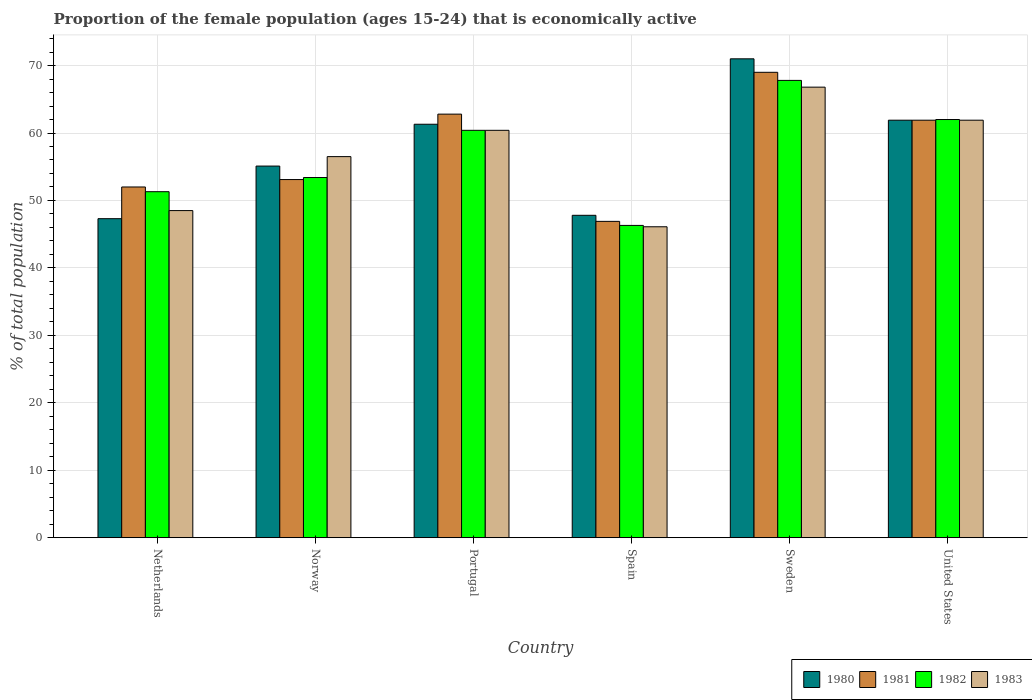Are the number of bars per tick equal to the number of legend labels?
Give a very brief answer. Yes. How many bars are there on the 1st tick from the left?
Make the answer very short. 4. What is the label of the 4th group of bars from the left?
Offer a very short reply. Spain. What is the proportion of the female population that is economically active in 1983 in Spain?
Give a very brief answer. 46.1. Across all countries, what is the maximum proportion of the female population that is economically active in 1982?
Offer a very short reply. 67.8. Across all countries, what is the minimum proportion of the female population that is economically active in 1980?
Your answer should be very brief. 47.3. What is the total proportion of the female population that is economically active in 1983 in the graph?
Make the answer very short. 340.2. What is the difference between the proportion of the female population that is economically active in 1983 in Norway and that in Portugal?
Provide a short and direct response. -3.9. What is the difference between the proportion of the female population that is economically active in 1980 in United States and the proportion of the female population that is economically active in 1981 in Sweden?
Make the answer very short. -7.1. What is the average proportion of the female population that is economically active in 1982 per country?
Make the answer very short. 56.87. What is the difference between the proportion of the female population that is economically active of/in 1980 and proportion of the female population that is economically active of/in 1982 in Sweden?
Ensure brevity in your answer.  3.2. In how many countries, is the proportion of the female population that is economically active in 1983 greater than 56 %?
Provide a short and direct response. 4. What is the ratio of the proportion of the female population that is economically active in 1983 in Portugal to that in United States?
Offer a very short reply. 0.98. Is the difference between the proportion of the female population that is economically active in 1980 in Norway and Spain greater than the difference between the proportion of the female population that is economically active in 1982 in Norway and Spain?
Offer a terse response. Yes. What is the difference between the highest and the second highest proportion of the female population that is economically active in 1980?
Keep it short and to the point. -0.6. What is the difference between the highest and the lowest proportion of the female population that is economically active in 1983?
Keep it short and to the point. 20.7. In how many countries, is the proportion of the female population that is economically active in 1981 greater than the average proportion of the female population that is economically active in 1981 taken over all countries?
Your answer should be compact. 3. Is it the case that in every country, the sum of the proportion of the female population that is economically active in 1983 and proportion of the female population that is economically active in 1980 is greater than the sum of proportion of the female population that is economically active in 1982 and proportion of the female population that is economically active in 1981?
Keep it short and to the point. No. What does the 4th bar from the right in United States represents?
Offer a terse response. 1980. How many bars are there?
Provide a short and direct response. 24. How many countries are there in the graph?
Keep it short and to the point. 6. What is the difference between two consecutive major ticks on the Y-axis?
Provide a short and direct response. 10. Does the graph contain any zero values?
Offer a terse response. No. Does the graph contain grids?
Your answer should be very brief. Yes. What is the title of the graph?
Ensure brevity in your answer.  Proportion of the female population (ages 15-24) that is economically active. Does "1961" appear as one of the legend labels in the graph?
Offer a very short reply. No. What is the label or title of the X-axis?
Your answer should be very brief. Country. What is the label or title of the Y-axis?
Give a very brief answer. % of total population. What is the % of total population in 1980 in Netherlands?
Your answer should be compact. 47.3. What is the % of total population in 1982 in Netherlands?
Give a very brief answer. 51.3. What is the % of total population in 1983 in Netherlands?
Offer a terse response. 48.5. What is the % of total population of 1980 in Norway?
Make the answer very short. 55.1. What is the % of total population of 1981 in Norway?
Your answer should be very brief. 53.1. What is the % of total population of 1982 in Norway?
Your answer should be compact. 53.4. What is the % of total population in 1983 in Norway?
Provide a succinct answer. 56.5. What is the % of total population in 1980 in Portugal?
Give a very brief answer. 61.3. What is the % of total population of 1981 in Portugal?
Offer a very short reply. 62.8. What is the % of total population of 1982 in Portugal?
Offer a terse response. 60.4. What is the % of total population in 1983 in Portugal?
Provide a succinct answer. 60.4. What is the % of total population in 1980 in Spain?
Give a very brief answer. 47.8. What is the % of total population of 1981 in Spain?
Your response must be concise. 46.9. What is the % of total population of 1982 in Spain?
Provide a short and direct response. 46.3. What is the % of total population of 1983 in Spain?
Make the answer very short. 46.1. What is the % of total population in 1980 in Sweden?
Make the answer very short. 71. What is the % of total population of 1981 in Sweden?
Provide a succinct answer. 69. What is the % of total population in 1982 in Sweden?
Your response must be concise. 67.8. What is the % of total population in 1983 in Sweden?
Make the answer very short. 66.8. What is the % of total population of 1980 in United States?
Ensure brevity in your answer.  61.9. What is the % of total population of 1981 in United States?
Provide a short and direct response. 61.9. What is the % of total population in 1982 in United States?
Make the answer very short. 62. What is the % of total population in 1983 in United States?
Your answer should be compact. 61.9. Across all countries, what is the maximum % of total population in 1982?
Give a very brief answer. 67.8. Across all countries, what is the maximum % of total population in 1983?
Provide a short and direct response. 66.8. Across all countries, what is the minimum % of total population in 1980?
Make the answer very short. 47.3. Across all countries, what is the minimum % of total population in 1981?
Offer a terse response. 46.9. Across all countries, what is the minimum % of total population in 1982?
Provide a succinct answer. 46.3. Across all countries, what is the minimum % of total population in 1983?
Give a very brief answer. 46.1. What is the total % of total population in 1980 in the graph?
Give a very brief answer. 344.4. What is the total % of total population in 1981 in the graph?
Your answer should be compact. 345.7. What is the total % of total population in 1982 in the graph?
Ensure brevity in your answer.  341.2. What is the total % of total population in 1983 in the graph?
Ensure brevity in your answer.  340.2. What is the difference between the % of total population of 1980 in Netherlands and that in Norway?
Make the answer very short. -7.8. What is the difference between the % of total population of 1981 in Netherlands and that in Norway?
Give a very brief answer. -1.1. What is the difference between the % of total population of 1982 in Netherlands and that in Norway?
Provide a short and direct response. -2.1. What is the difference between the % of total population in 1981 in Netherlands and that in Portugal?
Your answer should be very brief. -10.8. What is the difference between the % of total population of 1982 in Netherlands and that in Portugal?
Make the answer very short. -9.1. What is the difference between the % of total population of 1980 in Netherlands and that in Spain?
Provide a succinct answer. -0.5. What is the difference between the % of total population of 1981 in Netherlands and that in Spain?
Offer a very short reply. 5.1. What is the difference between the % of total population in 1983 in Netherlands and that in Spain?
Ensure brevity in your answer.  2.4. What is the difference between the % of total population in 1980 in Netherlands and that in Sweden?
Offer a very short reply. -23.7. What is the difference between the % of total population of 1982 in Netherlands and that in Sweden?
Offer a terse response. -16.5. What is the difference between the % of total population of 1983 in Netherlands and that in Sweden?
Your answer should be compact. -18.3. What is the difference between the % of total population of 1980 in Netherlands and that in United States?
Your response must be concise. -14.6. What is the difference between the % of total population of 1982 in Netherlands and that in United States?
Your response must be concise. -10.7. What is the difference between the % of total population in 1983 in Netherlands and that in United States?
Your answer should be compact. -13.4. What is the difference between the % of total population of 1981 in Norway and that in Portugal?
Provide a short and direct response. -9.7. What is the difference between the % of total population of 1982 in Norway and that in Portugal?
Offer a very short reply. -7. What is the difference between the % of total population in 1983 in Norway and that in Portugal?
Provide a succinct answer. -3.9. What is the difference between the % of total population of 1980 in Norway and that in Spain?
Offer a very short reply. 7.3. What is the difference between the % of total population in 1981 in Norway and that in Spain?
Ensure brevity in your answer.  6.2. What is the difference between the % of total population in 1982 in Norway and that in Spain?
Give a very brief answer. 7.1. What is the difference between the % of total population of 1983 in Norway and that in Spain?
Make the answer very short. 10.4. What is the difference between the % of total population of 1980 in Norway and that in Sweden?
Make the answer very short. -15.9. What is the difference between the % of total population of 1981 in Norway and that in Sweden?
Offer a terse response. -15.9. What is the difference between the % of total population of 1982 in Norway and that in Sweden?
Keep it short and to the point. -14.4. What is the difference between the % of total population of 1980 in Norway and that in United States?
Your response must be concise. -6.8. What is the difference between the % of total population in 1981 in Norway and that in United States?
Offer a very short reply. -8.8. What is the difference between the % of total population of 1980 in Portugal and that in Spain?
Provide a short and direct response. 13.5. What is the difference between the % of total population in 1983 in Portugal and that in Spain?
Keep it short and to the point. 14.3. What is the difference between the % of total population in 1981 in Portugal and that in Sweden?
Offer a terse response. -6.2. What is the difference between the % of total population in 1981 in Portugal and that in United States?
Your answer should be very brief. 0.9. What is the difference between the % of total population in 1982 in Portugal and that in United States?
Your answer should be compact. -1.6. What is the difference between the % of total population in 1983 in Portugal and that in United States?
Offer a terse response. -1.5. What is the difference between the % of total population of 1980 in Spain and that in Sweden?
Provide a short and direct response. -23.2. What is the difference between the % of total population of 1981 in Spain and that in Sweden?
Your response must be concise. -22.1. What is the difference between the % of total population in 1982 in Spain and that in Sweden?
Provide a succinct answer. -21.5. What is the difference between the % of total population of 1983 in Spain and that in Sweden?
Your answer should be compact. -20.7. What is the difference between the % of total population of 1980 in Spain and that in United States?
Keep it short and to the point. -14.1. What is the difference between the % of total population in 1982 in Spain and that in United States?
Provide a short and direct response. -15.7. What is the difference between the % of total population of 1983 in Spain and that in United States?
Provide a succinct answer. -15.8. What is the difference between the % of total population in 1980 in Sweden and that in United States?
Ensure brevity in your answer.  9.1. What is the difference between the % of total population of 1982 in Sweden and that in United States?
Offer a very short reply. 5.8. What is the difference between the % of total population of 1983 in Sweden and that in United States?
Provide a short and direct response. 4.9. What is the difference between the % of total population of 1980 in Netherlands and the % of total population of 1981 in Norway?
Your response must be concise. -5.8. What is the difference between the % of total population of 1980 in Netherlands and the % of total population of 1982 in Norway?
Provide a short and direct response. -6.1. What is the difference between the % of total population in 1980 in Netherlands and the % of total population in 1983 in Norway?
Offer a terse response. -9.2. What is the difference between the % of total population of 1980 in Netherlands and the % of total population of 1981 in Portugal?
Give a very brief answer. -15.5. What is the difference between the % of total population in 1980 in Netherlands and the % of total population in 1982 in Portugal?
Offer a very short reply. -13.1. What is the difference between the % of total population in 1980 in Netherlands and the % of total population in 1983 in Portugal?
Offer a very short reply. -13.1. What is the difference between the % of total population in 1981 in Netherlands and the % of total population in 1983 in Portugal?
Offer a terse response. -8.4. What is the difference between the % of total population in 1980 in Netherlands and the % of total population in 1982 in Spain?
Your response must be concise. 1. What is the difference between the % of total population in 1982 in Netherlands and the % of total population in 1983 in Spain?
Provide a short and direct response. 5.2. What is the difference between the % of total population of 1980 in Netherlands and the % of total population of 1981 in Sweden?
Make the answer very short. -21.7. What is the difference between the % of total population of 1980 in Netherlands and the % of total population of 1982 in Sweden?
Your answer should be very brief. -20.5. What is the difference between the % of total population in 1980 in Netherlands and the % of total population in 1983 in Sweden?
Provide a succinct answer. -19.5. What is the difference between the % of total population of 1981 in Netherlands and the % of total population of 1982 in Sweden?
Your answer should be very brief. -15.8. What is the difference between the % of total population of 1981 in Netherlands and the % of total population of 1983 in Sweden?
Give a very brief answer. -14.8. What is the difference between the % of total population in 1982 in Netherlands and the % of total population in 1983 in Sweden?
Provide a short and direct response. -15.5. What is the difference between the % of total population in 1980 in Netherlands and the % of total population in 1981 in United States?
Offer a terse response. -14.6. What is the difference between the % of total population in 1980 in Netherlands and the % of total population in 1982 in United States?
Provide a succinct answer. -14.7. What is the difference between the % of total population in 1980 in Netherlands and the % of total population in 1983 in United States?
Offer a terse response. -14.6. What is the difference between the % of total population of 1981 in Netherlands and the % of total population of 1983 in United States?
Your answer should be very brief. -9.9. What is the difference between the % of total population in 1980 in Norway and the % of total population in 1982 in Portugal?
Keep it short and to the point. -5.3. What is the difference between the % of total population in 1980 in Norway and the % of total population in 1983 in Portugal?
Your answer should be compact. -5.3. What is the difference between the % of total population in 1981 in Norway and the % of total population in 1983 in Portugal?
Offer a very short reply. -7.3. What is the difference between the % of total population of 1982 in Norway and the % of total population of 1983 in Portugal?
Your answer should be very brief. -7. What is the difference between the % of total population in 1980 in Norway and the % of total population in 1981 in Spain?
Ensure brevity in your answer.  8.2. What is the difference between the % of total population in 1980 in Norway and the % of total population in 1983 in Spain?
Give a very brief answer. 9. What is the difference between the % of total population in 1981 in Norway and the % of total population in 1982 in Spain?
Provide a succinct answer. 6.8. What is the difference between the % of total population in 1981 in Norway and the % of total population in 1983 in Spain?
Make the answer very short. 7. What is the difference between the % of total population in 1980 in Norway and the % of total population in 1981 in Sweden?
Your response must be concise. -13.9. What is the difference between the % of total population in 1980 in Norway and the % of total population in 1983 in Sweden?
Your answer should be compact. -11.7. What is the difference between the % of total population of 1981 in Norway and the % of total population of 1982 in Sweden?
Your answer should be very brief. -14.7. What is the difference between the % of total population of 1981 in Norway and the % of total population of 1983 in Sweden?
Keep it short and to the point. -13.7. What is the difference between the % of total population in 1982 in Norway and the % of total population in 1983 in Sweden?
Your answer should be very brief. -13.4. What is the difference between the % of total population of 1980 in Norway and the % of total population of 1981 in United States?
Offer a terse response. -6.8. What is the difference between the % of total population in 1981 in Norway and the % of total population in 1982 in United States?
Your answer should be compact. -8.9. What is the difference between the % of total population in 1981 in Norway and the % of total population in 1983 in United States?
Give a very brief answer. -8.8. What is the difference between the % of total population of 1982 in Norway and the % of total population of 1983 in United States?
Make the answer very short. -8.5. What is the difference between the % of total population in 1981 in Portugal and the % of total population in 1982 in Spain?
Offer a terse response. 16.5. What is the difference between the % of total population in 1982 in Portugal and the % of total population in 1983 in Spain?
Provide a short and direct response. 14.3. What is the difference between the % of total population in 1980 in Portugal and the % of total population in 1983 in Sweden?
Offer a terse response. -5.5. What is the difference between the % of total population in 1981 in Portugal and the % of total population in 1983 in United States?
Your response must be concise. 0.9. What is the difference between the % of total population of 1982 in Portugal and the % of total population of 1983 in United States?
Give a very brief answer. -1.5. What is the difference between the % of total population of 1980 in Spain and the % of total population of 1981 in Sweden?
Offer a very short reply. -21.2. What is the difference between the % of total population in 1980 in Spain and the % of total population in 1982 in Sweden?
Your answer should be very brief. -20. What is the difference between the % of total population in 1981 in Spain and the % of total population in 1982 in Sweden?
Make the answer very short. -20.9. What is the difference between the % of total population of 1981 in Spain and the % of total population of 1983 in Sweden?
Give a very brief answer. -19.9. What is the difference between the % of total population in 1982 in Spain and the % of total population in 1983 in Sweden?
Your answer should be compact. -20.5. What is the difference between the % of total population of 1980 in Spain and the % of total population of 1981 in United States?
Your answer should be compact. -14.1. What is the difference between the % of total population of 1980 in Spain and the % of total population of 1982 in United States?
Offer a terse response. -14.2. What is the difference between the % of total population in 1980 in Spain and the % of total population in 1983 in United States?
Offer a very short reply. -14.1. What is the difference between the % of total population of 1981 in Spain and the % of total population of 1982 in United States?
Give a very brief answer. -15.1. What is the difference between the % of total population of 1982 in Spain and the % of total population of 1983 in United States?
Provide a succinct answer. -15.6. What is the difference between the % of total population of 1982 in Sweden and the % of total population of 1983 in United States?
Provide a succinct answer. 5.9. What is the average % of total population of 1980 per country?
Offer a terse response. 57.4. What is the average % of total population of 1981 per country?
Offer a very short reply. 57.62. What is the average % of total population in 1982 per country?
Make the answer very short. 56.87. What is the average % of total population in 1983 per country?
Offer a very short reply. 56.7. What is the difference between the % of total population of 1981 and % of total population of 1982 in Netherlands?
Ensure brevity in your answer.  0.7. What is the difference between the % of total population of 1981 and % of total population of 1983 in Netherlands?
Provide a succinct answer. 3.5. What is the difference between the % of total population of 1982 and % of total population of 1983 in Netherlands?
Provide a short and direct response. 2.8. What is the difference between the % of total population in 1981 and % of total population in 1982 in Norway?
Your answer should be very brief. -0.3. What is the difference between the % of total population of 1980 and % of total population of 1982 in Portugal?
Keep it short and to the point. 0.9. What is the difference between the % of total population of 1980 and % of total population of 1983 in Portugal?
Provide a succinct answer. 0.9. What is the difference between the % of total population in 1981 and % of total population in 1982 in Portugal?
Give a very brief answer. 2.4. What is the difference between the % of total population of 1981 and % of total population of 1983 in Portugal?
Provide a succinct answer. 2.4. What is the difference between the % of total population of 1982 and % of total population of 1983 in Portugal?
Provide a short and direct response. 0. What is the difference between the % of total population in 1980 and % of total population in 1983 in Spain?
Ensure brevity in your answer.  1.7. What is the difference between the % of total population in 1981 and % of total population in 1982 in Spain?
Provide a succinct answer. 0.6. What is the difference between the % of total population of 1981 and % of total population of 1983 in Spain?
Provide a succinct answer. 0.8. What is the difference between the % of total population in 1982 and % of total population in 1983 in Spain?
Your answer should be compact. 0.2. What is the difference between the % of total population of 1980 and % of total population of 1981 in Sweden?
Your answer should be very brief. 2. What is the difference between the % of total population in 1982 and % of total population in 1983 in Sweden?
Keep it short and to the point. 1. What is the difference between the % of total population of 1980 and % of total population of 1982 in United States?
Your answer should be compact. -0.1. What is the difference between the % of total population in 1980 and % of total population in 1983 in United States?
Ensure brevity in your answer.  0. What is the difference between the % of total population in 1981 and % of total population in 1982 in United States?
Offer a terse response. -0.1. What is the difference between the % of total population of 1981 and % of total population of 1983 in United States?
Ensure brevity in your answer.  0. What is the ratio of the % of total population of 1980 in Netherlands to that in Norway?
Ensure brevity in your answer.  0.86. What is the ratio of the % of total population of 1981 in Netherlands to that in Norway?
Provide a short and direct response. 0.98. What is the ratio of the % of total population in 1982 in Netherlands to that in Norway?
Keep it short and to the point. 0.96. What is the ratio of the % of total population of 1983 in Netherlands to that in Norway?
Give a very brief answer. 0.86. What is the ratio of the % of total population in 1980 in Netherlands to that in Portugal?
Keep it short and to the point. 0.77. What is the ratio of the % of total population of 1981 in Netherlands to that in Portugal?
Your answer should be compact. 0.83. What is the ratio of the % of total population in 1982 in Netherlands to that in Portugal?
Offer a very short reply. 0.85. What is the ratio of the % of total population in 1983 in Netherlands to that in Portugal?
Offer a very short reply. 0.8. What is the ratio of the % of total population in 1981 in Netherlands to that in Spain?
Give a very brief answer. 1.11. What is the ratio of the % of total population in 1982 in Netherlands to that in Spain?
Your answer should be compact. 1.11. What is the ratio of the % of total population in 1983 in Netherlands to that in Spain?
Keep it short and to the point. 1.05. What is the ratio of the % of total population of 1980 in Netherlands to that in Sweden?
Provide a succinct answer. 0.67. What is the ratio of the % of total population of 1981 in Netherlands to that in Sweden?
Ensure brevity in your answer.  0.75. What is the ratio of the % of total population of 1982 in Netherlands to that in Sweden?
Your response must be concise. 0.76. What is the ratio of the % of total population of 1983 in Netherlands to that in Sweden?
Provide a succinct answer. 0.73. What is the ratio of the % of total population of 1980 in Netherlands to that in United States?
Your response must be concise. 0.76. What is the ratio of the % of total population of 1981 in Netherlands to that in United States?
Your answer should be compact. 0.84. What is the ratio of the % of total population of 1982 in Netherlands to that in United States?
Your response must be concise. 0.83. What is the ratio of the % of total population in 1983 in Netherlands to that in United States?
Ensure brevity in your answer.  0.78. What is the ratio of the % of total population of 1980 in Norway to that in Portugal?
Your answer should be compact. 0.9. What is the ratio of the % of total population in 1981 in Norway to that in Portugal?
Your answer should be compact. 0.85. What is the ratio of the % of total population in 1982 in Norway to that in Portugal?
Provide a short and direct response. 0.88. What is the ratio of the % of total population of 1983 in Norway to that in Portugal?
Offer a very short reply. 0.94. What is the ratio of the % of total population in 1980 in Norway to that in Spain?
Your answer should be very brief. 1.15. What is the ratio of the % of total population in 1981 in Norway to that in Spain?
Provide a succinct answer. 1.13. What is the ratio of the % of total population in 1982 in Norway to that in Spain?
Keep it short and to the point. 1.15. What is the ratio of the % of total population in 1983 in Norway to that in Spain?
Make the answer very short. 1.23. What is the ratio of the % of total population in 1980 in Norway to that in Sweden?
Ensure brevity in your answer.  0.78. What is the ratio of the % of total population in 1981 in Norway to that in Sweden?
Provide a short and direct response. 0.77. What is the ratio of the % of total population in 1982 in Norway to that in Sweden?
Keep it short and to the point. 0.79. What is the ratio of the % of total population in 1983 in Norway to that in Sweden?
Your response must be concise. 0.85. What is the ratio of the % of total population of 1980 in Norway to that in United States?
Give a very brief answer. 0.89. What is the ratio of the % of total population of 1981 in Norway to that in United States?
Ensure brevity in your answer.  0.86. What is the ratio of the % of total population of 1982 in Norway to that in United States?
Provide a short and direct response. 0.86. What is the ratio of the % of total population of 1983 in Norway to that in United States?
Make the answer very short. 0.91. What is the ratio of the % of total population in 1980 in Portugal to that in Spain?
Give a very brief answer. 1.28. What is the ratio of the % of total population in 1981 in Portugal to that in Spain?
Your answer should be compact. 1.34. What is the ratio of the % of total population of 1982 in Portugal to that in Spain?
Give a very brief answer. 1.3. What is the ratio of the % of total population in 1983 in Portugal to that in Spain?
Offer a very short reply. 1.31. What is the ratio of the % of total population in 1980 in Portugal to that in Sweden?
Your answer should be very brief. 0.86. What is the ratio of the % of total population in 1981 in Portugal to that in Sweden?
Provide a succinct answer. 0.91. What is the ratio of the % of total population in 1982 in Portugal to that in Sweden?
Provide a short and direct response. 0.89. What is the ratio of the % of total population in 1983 in Portugal to that in Sweden?
Make the answer very short. 0.9. What is the ratio of the % of total population of 1980 in Portugal to that in United States?
Your answer should be very brief. 0.99. What is the ratio of the % of total population in 1981 in Portugal to that in United States?
Your answer should be compact. 1.01. What is the ratio of the % of total population of 1982 in Portugal to that in United States?
Ensure brevity in your answer.  0.97. What is the ratio of the % of total population of 1983 in Portugal to that in United States?
Your response must be concise. 0.98. What is the ratio of the % of total population in 1980 in Spain to that in Sweden?
Ensure brevity in your answer.  0.67. What is the ratio of the % of total population in 1981 in Spain to that in Sweden?
Your response must be concise. 0.68. What is the ratio of the % of total population in 1982 in Spain to that in Sweden?
Your answer should be compact. 0.68. What is the ratio of the % of total population in 1983 in Spain to that in Sweden?
Your answer should be compact. 0.69. What is the ratio of the % of total population of 1980 in Spain to that in United States?
Keep it short and to the point. 0.77. What is the ratio of the % of total population in 1981 in Spain to that in United States?
Your answer should be compact. 0.76. What is the ratio of the % of total population of 1982 in Spain to that in United States?
Ensure brevity in your answer.  0.75. What is the ratio of the % of total population in 1983 in Spain to that in United States?
Make the answer very short. 0.74. What is the ratio of the % of total population of 1980 in Sweden to that in United States?
Your response must be concise. 1.15. What is the ratio of the % of total population in 1981 in Sweden to that in United States?
Your answer should be compact. 1.11. What is the ratio of the % of total population in 1982 in Sweden to that in United States?
Ensure brevity in your answer.  1.09. What is the ratio of the % of total population in 1983 in Sweden to that in United States?
Provide a succinct answer. 1.08. What is the difference between the highest and the second highest % of total population in 1982?
Make the answer very short. 5.8. What is the difference between the highest and the second highest % of total population in 1983?
Offer a very short reply. 4.9. What is the difference between the highest and the lowest % of total population of 1980?
Offer a very short reply. 23.7. What is the difference between the highest and the lowest % of total population of 1981?
Provide a succinct answer. 22.1. What is the difference between the highest and the lowest % of total population in 1983?
Provide a succinct answer. 20.7. 